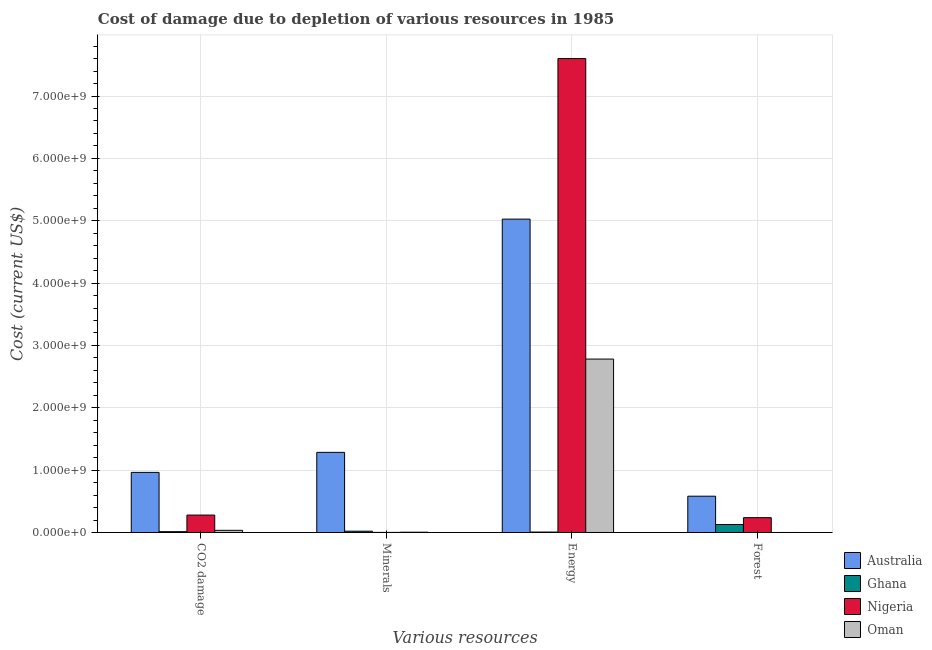Are the number of bars on each tick of the X-axis equal?
Ensure brevity in your answer.  Yes. How many bars are there on the 3rd tick from the right?
Your answer should be compact. 4. What is the label of the 3rd group of bars from the left?
Your answer should be very brief. Energy. What is the cost of damage due to depletion of energy in Australia?
Offer a very short reply. 5.03e+09. Across all countries, what is the maximum cost of damage due to depletion of forests?
Offer a very short reply. 5.82e+08. Across all countries, what is the minimum cost of damage due to depletion of forests?
Ensure brevity in your answer.  1.15e+05. In which country was the cost of damage due to depletion of coal maximum?
Offer a terse response. Australia. In which country was the cost of damage due to depletion of forests minimum?
Your response must be concise. Oman. What is the total cost of damage due to depletion of forests in the graph?
Make the answer very short. 9.48e+08. What is the difference between the cost of damage due to depletion of minerals in Ghana and that in Nigeria?
Your answer should be very brief. 1.95e+07. What is the difference between the cost of damage due to depletion of energy in Oman and the cost of damage due to depletion of coal in Australia?
Ensure brevity in your answer.  1.82e+09. What is the average cost of damage due to depletion of coal per country?
Provide a short and direct response. 3.23e+08. What is the difference between the cost of damage due to depletion of forests and cost of damage due to depletion of energy in Australia?
Give a very brief answer. -4.44e+09. What is the ratio of the cost of damage due to depletion of minerals in Oman to that in Ghana?
Your response must be concise. 0.21. Is the cost of damage due to depletion of coal in Nigeria less than that in Australia?
Offer a very short reply. Yes. What is the difference between the highest and the second highest cost of damage due to depletion of minerals?
Make the answer very short. 1.26e+09. What is the difference between the highest and the lowest cost of damage due to depletion of minerals?
Your answer should be compact. 1.28e+09. In how many countries, is the cost of damage due to depletion of minerals greater than the average cost of damage due to depletion of minerals taken over all countries?
Provide a short and direct response. 1. Is it the case that in every country, the sum of the cost of damage due to depletion of energy and cost of damage due to depletion of minerals is greater than the sum of cost of damage due to depletion of coal and cost of damage due to depletion of forests?
Provide a short and direct response. No. What does the 2nd bar from the left in Minerals represents?
Provide a short and direct response. Ghana. How many bars are there?
Make the answer very short. 16. Are all the bars in the graph horizontal?
Ensure brevity in your answer.  No. What is the difference between two consecutive major ticks on the Y-axis?
Provide a short and direct response. 1.00e+09. Does the graph contain any zero values?
Offer a terse response. No. Where does the legend appear in the graph?
Keep it short and to the point. Bottom right. How are the legend labels stacked?
Ensure brevity in your answer.  Vertical. What is the title of the graph?
Make the answer very short. Cost of damage due to depletion of various resources in 1985 . Does "Togo" appear as one of the legend labels in the graph?
Offer a terse response. No. What is the label or title of the X-axis?
Your response must be concise. Various resources. What is the label or title of the Y-axis?
Make the answer very short. Cost (current US$). What is the Cost (current US$) in Australia in CO2 damage?
Ensure brevity in your answer.  9.64e+08. What is the Cost (current US$) of Ghana in CO2 damage?
Your answer should be compact. 1.33e+07. What is the Cost (current US$) of Nigeria in CO2 damage?
Make the answer very short. 2.79e+08. What is the Cost (current US$) in Oman in CO2 damage?
Your response must be concise. 3.46e+07. What is the Cost (current US$) in Australia in Minerals?
Offer a very short reply. 1.29e+09. What is the Cost (current US$) of Ghana in Minerals?
Give a very brief answer. 2.08e+07. What is the Cost (current US$) of Nigeria in Minerals?
Your response must be concise. 1.25e+06. What is the Cost (current US$) in Oman in Minerals?
Your answer should be very brief. 4.45e+06. What is the Cost (current US$) in Australia in Energy?
Offer a very short reply. 5.03e+09. What is the Cost (current US$) in Ghana in Energy?
Make the answer very short. 6.95e+06. What is the Cost (current US$) in Nigeria in Energy?
Offer a very short reply. 7.60e+09. What is the Cost (current US$) of Oman in Energy?
Offer a very short reply. 2.78e+09. What is the Cost (current US$) in Australia in Forest?
Make the answer very short. 5.82e+08. What is the Cost (current US$) in Ghana in Forest?
Provide a succinct answer. 1.28e+08. What is the Cost (current US$) in Nigeria in Forest?
Provide a succinct answer. 2.38e+08. What is the Cost (current US$) of Oman in Forest?
Your answer should be very brief. 1.15e+05. Across all Various resources, what is the maximum Cost (current US$) in Australia?
Make the answer very short. 5.03e+09. Across all Various resources, what is the maximum Cost (current US$) of Ghana?
Keep it short and to the point. 1.28e+08. Across all Various resources, what is the maximum Cost (current US$) of Nigeria?
Offer a terse response. 7.60e+09. Across all Various resources, what is the maximum Cost (current US$) in Oman?
Your response must be concise. 2.78e+09. Across all Various resources, what is the minimum Cost (current US$) of Australia?
Your answer should be very brief. 5.82e+08. Across all Various resources, what is the minimum Cost (current US$) of Ghana?
Offer a very short reply. 6.95e+06. Across all Various resources, what is the minimum Cost (current US$) of Nigeria?
Your answer should be very brief. 1.25e+06. Across all Various resources, what is the minimum Cost (current US$) of Oman?
Provide a short and direct response. 1.15e+05. What is the total Cost (current US$) of Australia in the graph?
Make the answer very short. 7.86e+09. What is the total Cost (current US$) of Ghana in the graph?
Offer a terse response. 1.69e+08. What is the total Cost (current US$) of Nigeria in the graph?
Offer a very short reply. 8.12e+09. What is the total Cost (current US$) of Oman in the graph?
Give a very brief answer. 2.82e+09. What is the difference between the Cost (current US$) in Australia in CO2 damage and that in Minerals?
Offer a terse response. -3.21e+08. What is the difference between the Cost (current US$) of Ghana in CO2 damage and that in Minerals?
Offer a terse response. -7.49e+06. What is the difference between the Cost (current US$) of Nigeria in CO2 damage and that in Minerals?
Keep it short and to the point. 2.78e+08. What is the difference between the Cost (current US$) of Oman in CO2 damage and that in Minerals?
Your answer should be compact. 3.02e+07. What is the difference between the Cost (current US$) in Australia in CO2 damage and that in Energy?
Provide a succinct answer. -4.06e+09. What is the difference between the Cost (current US$) of Ghana in CO2 damage and that in Energy?
Offer a terse response. 6.34e+06. What is the difference between the Cost (current US$) in Nigeria in CO2 damage and that in Energy?
Keep it short and to the point. -7.32e+09. What is the difference between the Cost (current US$) of Oman in CO2 damage and that in Energy?
Provide a succinct answer. -2.75e+09. What is the difference between the Cost (current US$) of Australia in CO2 damage and that in Forest?
Provide a succinct answer. 3.82e+08. What is the difference between the Cost (current US$) in Ghana in CO2 damage and that in Forest?
Give a very brief answer. -1.15e+08. What is the difference between the Cost (current US$) of Nigeria in CO2 damage and that in Forest?
Give a very brief answer. 4.16e+07. What is the difference between the Cost (current US$) of Oman in CO2 damage and that in Forest?
Your response must be concise. 3.45e+07. What is the difference between the Cost (current US$) of Australia in Minerals and that in Energy?
Your answer should be very brief. -3.74e+09. What is the difference between the Cost (current US$) of Ghana in Minerals and that in Energy?
Give a very brief answer. 1.38e+07. What is the difference between the Cost (current US$) in Nigeria in Minerals and that in Energy?
Keep it short and to the point. -7.60e+09. What is the difference between the Cost (current US$) in Oman in Minerals and that in Energy?
Your answer should be compact. -2.78e+09. What is the difference between the Cost (current US$) in Australia in Minerals and that in Forest?
Give a very brief answer. 7.03e+08. What is the difference between the Cost (current US$) in Ghana in Minerals and that in Forest?
Your answer should be very brief. -1.07e+08. What is the difference between the Cost (current US$) of Nigeria in Minerals and that in Forest?
Keep it short and to the point. -2.36e+08. What is the difference between the Cost (current US$) in Oman in Minerals and that in Forest?
Your response must be concise. 4.34e+06. What is the difference between the Cost (current US$) in Australia in Energy and that in Forest?
Your answer should be very brief. 4.44e+09. What is the difference between the Cost (current US$) in Ghana in Energy and that in Forest?
Keep it short and to the point. -1.21e+08. What is the difference between the Cost (current US$) of Nigeria in Energy and that in Forest?
Your answer should be very brief. 7.36e+09. What is the difference between the Cost (current US$) of Oman in Energy and that in Forest?
Provide a succinct answer. 2.78e+09. What is the difference between the Cost (current US$) of Australia in CO2 damage and the Cost (current US$) of Ghana in Minerals?
Your answer should be compact. 9.43e+08. What is the difference between the Cost (current US$) in Australia in CO2 damage and the Cost (current US$) in Nigeria in Minerals?
Your response must be concise. 9.63e+08. What is the difference between the Cost (current US$) of Australia in CO2 damage and the Cost (current US$) of Oman in Minerals?
Make the answer very short. 9.59e+08. What is the difference between the Cost (current US$) of Ghana in CO2 damage and the Cost (current US$) of Nigeria in Minerals?
Give a very brief answer. 1.20e+07. What is the difference between the Cost (current US$) of Ghana in CO2 damage and the Cost (current US$) of Oman in Minerals?
Ensure brevity in your answer.  8.84e+06. What is the difference between the Cost (current US$) in Nigeria in CO2 damage and the Cost (current US$) in Oman in Minerals?
Your answer should be very brief. 2.75e+08. What is the difference between the Cost (current US$) in Australia in CO2 damage and the Cost (current US$) in Ghana in Energy?
Provide a short and direct response. 9.57e+08. What is the difference between the Cost (current US$) in Australia in CO2 damage and the Cost (current US$) in Nigeria in Energy?
Make the answer very short. -6.64e+09. What is the difference between the Cost (current US$) of Australia in CO2 damage and the Cost (current US$) of Oman in Energy?
Ensure brevity in your answer.  -1.82e+09. What is the difference between the Cost (current US$) of Ghana in CO2 damage and the Cost (current US$) of Nigeria in Energy?
Ensure brevity in your answer.  -7.59e+09. What is the difference between the Cost (current US$) of Ghana in CO2 damage and the Cost (current US$) of Oman in Energy?
Offer a very short reply. -2.77e+09. What is the difference between the Cost (current US$) in Nigeria in CO2 damage and the Cost (current US$) in Oman in Energy?
Ensure brevity in your answer.  -2.50e+09. What is the difference between the Cost (current US$) in Australia in CO2 damage and the Cost (current US$) in Ghana in Forest?
Give a very brief answer. 8.36e+08. What is the difference between the Cost (current US$) in Australia in CO2 damage and the Cost (current US$) in Nigeria in Forest?
Make the answer very short. 7.26e+08. What is the difference between the Cost (current US$) in Australia in CO2 damage and the Cost (current US$) in Oman in Forest?
Offer a terse response. 9.64e+08. What is the difference between the Cost (current US$) in Ghana in CO2 damage and the Cost (current US$) in Nigeria in Forest?
Ensure brevity in your answer.  -2.24e+08. What is the difference between the Cost (current US$) of Ghana in CO2 damage and the Cost (current US$) of Oman in Forest?
Provide a succinct answer. 1.32e+07. What is the difference between the Cost (current US$) in Nigeria in CO2 damage and the Cost (current US$) in Oman in Forest?
Your answer should be compact. 2.79e+08. What is the difference between the Cost (current US$) of Australia in Minerals and the Cost (current US$) of Ghana in Energy?
Your response must be concise. 1.28e+09. What is the difference between the Cost (current US$) of Australia in Minerals and the Cost (current US$) of Nigeria in Energy?
Your response must be concise. -6.32e+09. What is the difference between the Cost (current US$) of Australia in Minerals and the Cost (current US$) of Oman in Energy?
Offer a terse response. -1.50e+09. What is the difference between the Cost (current US$) of Ghana in Minerals and the Cost (current US$) of Nigeria in Energy?
Give a very brief answer. -7.58e+09. What is the difference between the Cost (current US$) of Ghana in Minerals and the Cost (current US$) of Oman in Energy?
Ensure brevity in your answer.  -2.76e+09. What is the difference between the Cost (current US$) of Nigeria in Minerals and the Cost (current US$) of Oman in Energy?
Offer a very short reply. -2.78e+09. What is the difference between the Cost (current US$) of Australia in Minerals and the Cost (current US$) of Ghana in Forest?
Your response must be concise. 1.16e+09. What is the difference between the Cost (current US$) in Australia in Minerals and the Cost (current US$) in Nigeria in Forest?
Your response must be concise. 1.05e+09. What is the difference between the Cost (current US$) in Australia in Minerals and the Cost (current US$) in Oman in Forest?
Your response must be concise. 1.28e+09. What is the difference between the Cost (current US$) in Ghana in Minerals and the Cost (current US$) in Nigeria in Forest?
Keep it short and to the point. -2.17e+08. What is the difference between the Cost (current US$) of Ghana in Minerals and the Cost (current US$) of Oman in Forest?
Make the answer very short. 2.07e+07. What is the difference between the Cost (current US$) of Nigeria in Minerals and the Cost (current US$) of Oman in Forest?
Give a very brief answer. 1.14e+06. What is the difference between the Cost (current US$) of Australia in Energy and the Cost (current US$) of Ghana in Forest?
Keep it short and to the point. 4.90e+09. What is the difference between the Cost (current US$) in Australia in Energy and the Cost (current US$) in Nigeria in Forest?
Your answer should be compact. 4.79e+09. What is the difference between the Cost (current US$) of Australia in Energy and the Cost (current US$) of Oman in Forest?
Keep it short and to the point. 5.03e+09. What is the difference between the Cost (current US$) in Ghana in Energy and the Cost (current US$) in Nigeria in Forest?
Provide a short and direct response. -2.31e+08. What is the difference between the Cost (current US$) in Ghana in Energy and the Cost (current US$) in Oman in Forest?
Ensure brevity in your answer.  6.84e+06. What is the difference between the Cost (current US$) in Nigeria in Energy and the Cost (current US$) in Oman in Forest?
Provide a succinct answer. 7.60e+09. What is the average Cost (current US$) in Australia per Various resources?
Provide a short and direct response. 1.96e+09. What is the average Cost (current US$) in Ghana per Various resources?
Ensure brevity in your answer.  4.22e+07. What is the average Cost (current US$) of Nigeria per Various resources?
Keep it short and to the point. 2.03e+09. What is the average Cost (current US$) in Oman per Various resources?
Your response must be concise. 7.05e+08. What is the difference between the Cost (current US$) in Australia and Cost (current US$) in Ghana in CO2 damage?
Your answer should be very brief. 9.51e+08. What is the difference between the Cost (current US$) in Australia and Cost (current US$) in Nigeria in CO2 damage?
Your answer should be very brief. 6.85e+08. What is the difference between the Cost (current US$) of Australia and Cost (current US$) of Oman in CO2 damage?
Your answer should be compact. 9.29e+08. What is the difference between the Cost (current US$) in Ghana and Cost (current US$) in Nigeria in CO2 damage?
Provide a short and direct response. -2.66e+08. What is the difference between the Cost (current US$) of Ghana and Cost (current US$) of Oman in CO2 damage?
Your answer should be compact. -2.13e+07. What is the difference between the Cost (current US$) in Nigeria and Cost (current US$) in Oman in CO2 damage?
Provide a succinct answer. 2.45e+08. What is the difference between the Cost (current US$) of Australia and Cost (current US$) of Ghana in Minerals?
Provide a succinct answer. 1.26e+09. What is the difference between the Cost (current US$) of Australia and Cost (current US$) of Nigeria in Minerals?
Keep it short and to the point. 1.28e+09. What is the difference between the Cost (current US$) in Australia and Cost (current US$) in Oman in Minerals?
Your answer should be very brief. 1.28e+09. What is the difference between the Cost (current US$) of Ghana and Cost (current US$) of Nigeria in Minerals?
Offer a terse response. 1.95e+07. What is the difference between the Cost (current US$) of Ghana and Cost (current US$) of Oman in Minerals?
Provide a short and direct response. 1.63e+07. What is the difference between the Cost (current US$) in Nigeria and Cost (current US$) in Oman in Minerals?
Make the answer very short. -3.20e+06. What is the difference between the Cost (current US$) of Australia and Cost (current US$) of Ghana in Energy?
Your response must be concise. 5.02e+09. What is the difference between the Cost (current US$) in Australia and Cost (current US$) in Nigeria in Energy?
Provide a short and direct response. -2.57e+09. What is the difference between the Cost (current US$) of Australia and Cost (current US$) of Oman in Energy?
Give a very brief answer. 2.24e+09. What is the difference between the Cost (current US$) of Ghana and Cost (current US$) of Nigeria in Energy?
Your answer should be compact. -7.59e+09. What is the difference between the Cost (current US$) of Ghana and Cost (current US$) of Oman in Energy?
Give a very brief answer. -2.77e+09. What is the difference between the Cost (current US$) of Nigeria and Cost (current US$) of Oman in Energy?
Provide a succinct answer. 4.82e+09. What is the difference between the Cost (current US$) of Australia and Cost (current US$) of Ghana in Forest?
Ensure brevity in your answer.  4.54e+08. What is the difference between the Cost (current US$) of Australia and Cost (current US$) of Nigeria in Forest?
Offer a very short reply. 3.44e+08. What is the difference between the Cost (current US$) in Australia and Cost (current US$) in Oman in Forest?
Ensure brevity in your answer.  5.82e+08. What is the difference between the Cost (current US$) in Ghana and Cost (current US$) in Nigeria in Forest?
Offer a terse response. -1.10e+08. What is the difference between the Cost (current US$) of Ghana and Cost (current US$) of Oman in Forest?
Ensure brevity in your answer.  1.28e+08. What is the difference between the Cost (current US$) of Nigeria and Cost (current US$) of Oman in Forest?
Provide a succinct answer. 2.38e+08. What is the ratio of the Cost (current US$) in Australia in CO2 damage to that in Minerals?
Provide a succinct answer. 0.75. What is the ratio of the Cost (current US$) in Ghana in CO2 damage to that in Minerals?
Ensure brevity in your answer.  0.64. What is the ratio of the Cost (current US$) of Nigeria in CO2 damage to that in Minerals?
Your response must be concise. 223.34. What is the ratio of the Cost (current US$) of Oman in CO2 damage to that in Minerals?
Ensure brevity in your answer.  7.77. What is the ratio of the Cost (current US$) of Australia in CO2 damage to that in Energy?
Provide a short and direct response. 0.19. What is the ratio of the Cost (current US$) in Ghana in CO2 damage to that in Energy?
Offer a very short reply. 1.91. What is the ratio of the Cost (current US$) of Nigeria in CO2 damage to that in Energy?
Offer a terse response. 0.04. What is the ratio of the Cost (current US$) of Oman in CO2 damage to that in Energy?
Your answer should be very brief. 0.01. What is the ratio of the Cost (current US$) in Australia in CO2 damage to that in Forest?
Your response must be concise. 1.66. What is the ratio of the Cost (current US$) of Ghana in CO2 damage to that in Forest?
Provide a short and direct response. 0.1. What is the ratio of the Cost (current US$) in Nigeria in CO2 damage to that in Forest?
Provide a succinct answer. 1.18. What is the ratio of the Cost (current US$) of Oman in CO2 damage to that in Forest?
Offer a very short reply. 300.44. What is the ratio of the Cost (current US$) of Australia in Minerals to that in Energy?
Make the answer very short. 0.26. What is the ratio of the Cost (current US$) of Ghana in Minerals to that in Energy?
Your answer should be compact. 2.99. What is the ratio of the Cost (current US$) in Oman in Minerals to that in Energy?
Make the answer very short. 0. What is the ratio of the Cost (current US$) of Australia in Minerals to that in Forest?
Make the answer very short. 2.21. What is the ratio of the Cost (current US$) in Ghana in Minerals to that in Forest?
Make the answer very short. 0.16. What is the ratio of the Cost (current US$) of Nigeria in Minerals to that in Forest?
Make the answer very short. 0.01. What is the ratio of the Cost (current US$) in Oman in Minerals to that in Forest?
Your answer should be compact. 38.65. What is the ratio of the Cost (current US$) of Australia in Energy to that in Forest?
Offer a very short reply. 8.63. What is the ratio of the Cost (current US$) in Ghana in Energy to that in Forest?
Make the answer very short. 0.05. What is the ratio of the Cost (current US$) in Nigeria in Energy to that in Forest?
Your answer should be very brief. 31.98. What is the ratio of the Cost (current US$) in Oman in Energy to that in Forest?
Ensure brevity in your answer.  2.41e+04. What is the difference between the highest and the second highest Cost (current US$) of Australia?
Your answer should be very brief. 3.74e+09. What is the difference between the highest and the second highest Cost (current US$) of Ghana?
Your answer should be very brief. 1.07e+08. What is the difference between the highest and the second highest Cost (current US$) of Nigeria?
Ensure brevity in your answer.  7.32e+09. What is the difference between the highest and the second highest Cost (current US$) in Oman?
Your answer should be compact. 2.75e+09. What is the difference between the highest and the lowest Cost (current US$) of Australia?
Give a very brief answer. 4.44e+09. What is the difference between the highest and the lowest Cost (current US$) in Ghana?
Provide a succinct answer. 1.21e+08. What is the difference between the highest and the lowest Cost (current US$) of Nigeria?
Your response must be concise. 7.60e+09. What is the difference between the highest and the lowest Cost (current US$) in Oman?
Give a very brief answer. 2.78e+09. 